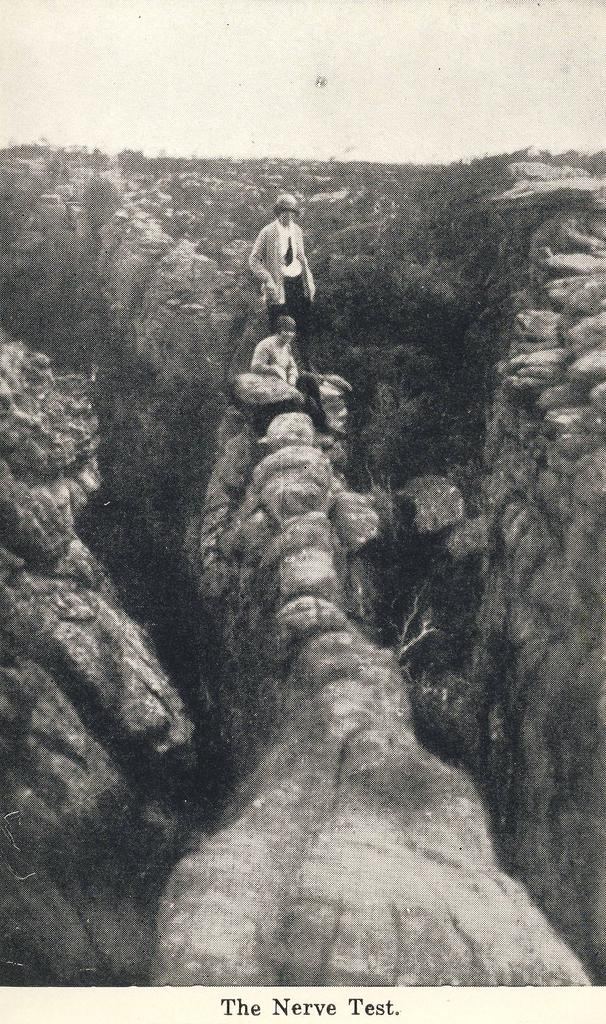What can be inferred about the age of the image? The image is old. What type of landscape is depicted in the image? There are hills and rocks in the image. What is the sitting man doing in the image? The sitting man is sitting on one of the hills. Who else is present in the image? Another person is standing behind the sitting man. What advice does the creator of the image give to the viewer? There is no indication in the image that it was created with a specific message or advice for the viewer. 